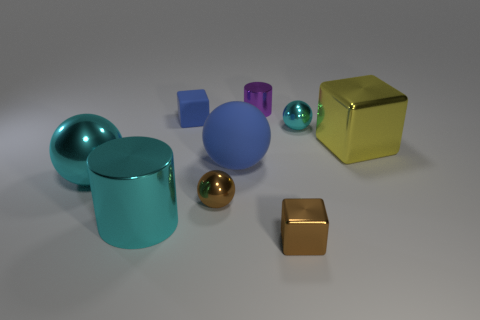Subtract all small brown cubes. How many cubes are left? 2 Subtract all yellow cubes. How many cubes are left? 2 Subtract all cylinders. How many objects are left? 7 Add 1 large cyan cylinders. How many objects exist? 10 Subtract 3 spheres. How many spheres are left? 1 Subtract all red spheres. Subtract all gray cubes. How many spheres are left? 4 Subtract all blue cylinders. How many blue balls are left? 1 Subtract all rubber spheres. Subtract all large matte balls. How many objects are left? 7 Add 2 tiny blue rubber things. How many tiny blue rubber things are left? 3 Add 1 small blue shiny cylinders. How many small blue shiny cylinders exist? 1 